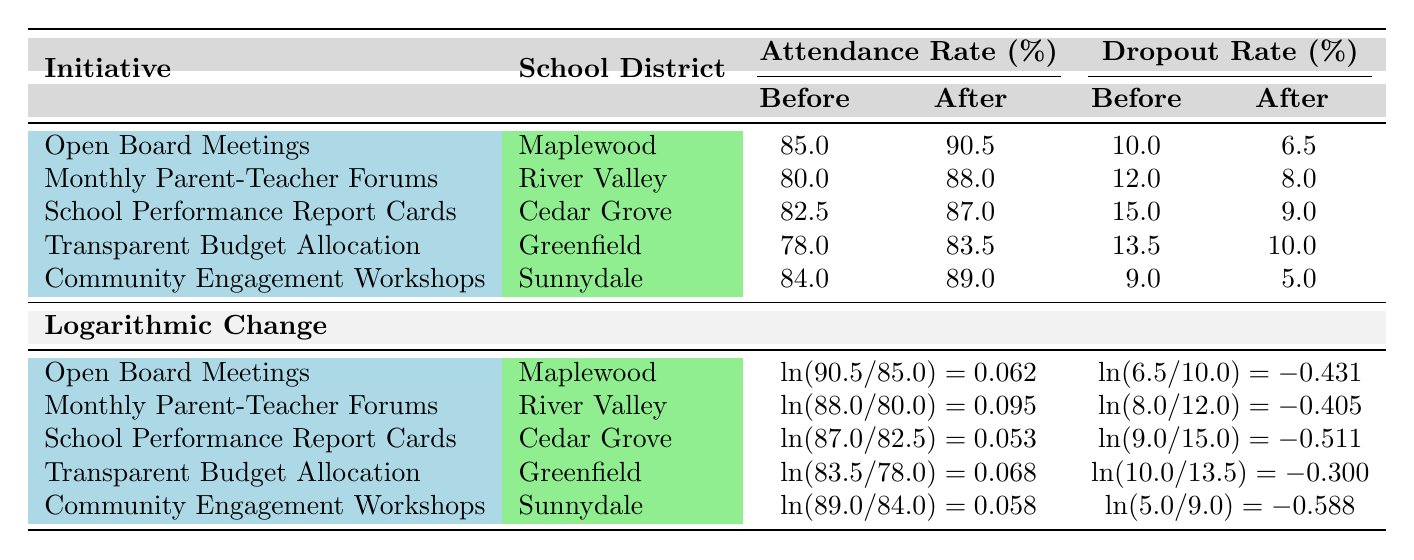What was the attendance rate in Maplewood School District before the initiative? The table shows that the attendance rate before the initiative "Open Board Meetings" in Maplewood School District was 85.0%.
Answer: 85.0% Which district experienced the largest decrease in dropout rate? To find the largest decrease in dropout rates, we can compare the "Before" and "After" dropout rates for each district. The largest decrease is from 9.0% to 5.0% in Sunnydale School District, which represents a decrease of 4.0%.
Answer: Sunnydale School District What is the total change in attendance rate after implementing the "Monthly Parent-Teacher Forums"? The attendance rates before and after for "Monthly Parent-Teacher Forums" in River Valley are 80.0% and 88.0%, respectively. The total change is 88.0% - 80.0% = 8.0%.
Answer: 8.0% Is the attendance rate after the initiative higher in Cedar Grove or Greenfield? The attendance rate after the initiatives for Cedar Grove is 87.0% and for Greenfield is 83.5%. Since 87.0% > 83.5%, Cedar Grove has a higher attendance rate after the initiative.
Answer: Yes What is the average dropout rate after all initiatives have been implemented? The dropout rates after the initiatives are: 6.5%, 8.0%, 9.0%, 10.0%, and 5.0%. To find the average, we sum these: (6.5 + 8.0 + 9.0 + 10.0 + 5.0) = 38.5%. There are 5 districts, so the average is 38.5% / 5 = 7.7%.
Answer: 7.7% 